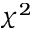<formula> <loc_0><loc_0><loc_500><loc_500>\chi ^ { 2 }</formula> 